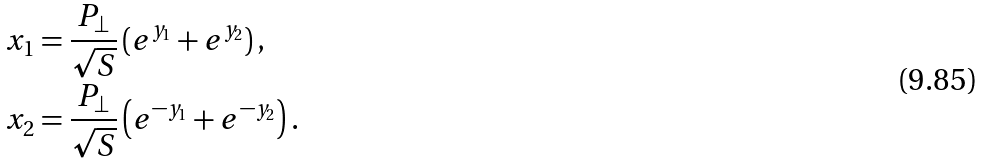Convert formula to latex. <formula><loc_0><loc_0><loc_500><loc_500>x _ { 1 } & = \frac { P _ { \perp } } { \sqrt { S } } \left ( e ^ { y _ { 1 } } + e ^ { y _ { 2 } } \right ) , \\ x _ { 2 } & = \frac { P _ { \perp } } { \sqrt { S } } \left ( e ^ { - y _ { 1 } } + e ^ { - y _ { 2 } } \right ) .</formula> 